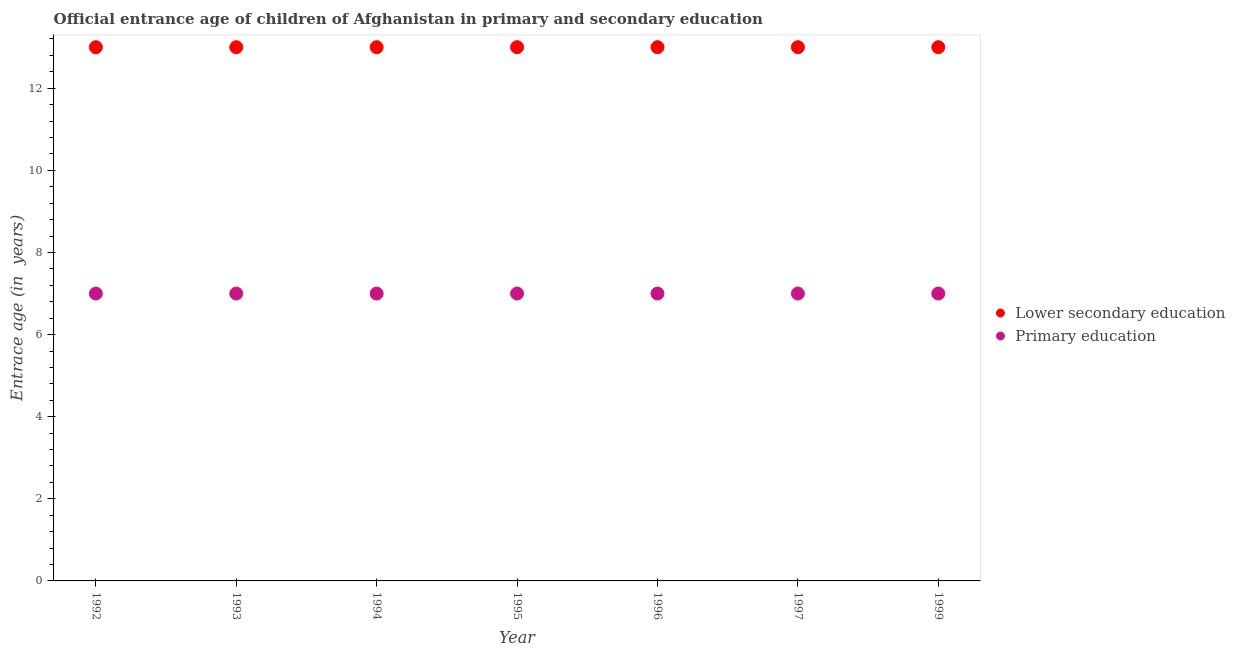What is the entrance age of children in lower secondary education in 1999?
Ensure brevity in your answer.  13. Across all years, what is the maximum entrance age of children in lower secondary education?
Your answer should be very brief. 13. Across all years, what is the minimum entrance age of children in lower secondary education?
Offer a terse response. 13. In which year was the entrance age of children in lower secondary education minimum?
Make the answer very short. 1992. What is the total entrance age of chiildren in primary education in the graph?
Provide a succinct answer. 49. What is the difference between the entrance age of chiildren in primary education in 1995 and that in 1999?
Offer a very short reply. 0. What is the difference between the entrance age of chiildren in primary education in 1995 and the entrance age of children in lower secondary education in 1992?
Keep it short and to the point. -6. In the year 1994, what is the difference between the entrance age of chiildren in primary education and entrance age of children in lower secondary education?
Your answer should be very brief. -6. In how many years, is the entrance age of children in lower secondary education greater than 4 years?
Provide a succinct answer. 7. Is the entrance age of chiildren in primary education in 1997 less than that in 1999?
Your answer should be compact. No. What is the difference between the highest and the second highest entrance age of children in lower secondary education?
Offer a terse response. 0. What is the difference between the highest and the lowest entrance age of children in lower secondary education?
Make the answer very short. 0. In how many years, is the entrance age of chiildren in primary education greater than the average entrance age of chiildren in primary education taken over all years?
Keep it short and to the point. 0. Does the entrance age of chiildren in primary education monotonically increase over the years?
Give a very brief answer. No. Is the entrance age of chiildren in primary education strictly less than the entrance age of children in lower secondary education over the years?
Make the answer very short. Yes. How many dotlines are there?
Provide a succinct answer. 2. How many legend labels are there?
Your response must be concise. 2. How are the legend labels stacked?
Your response must be concise. Vertical. What is the title of the graph?
Keep it short and to the point. Official entrance age of children of Afghanistan in primary and secondary education. What is the label or title of the Y-axis?
Ensure brevity in your answer.  Entrace age (in  years). What is the Entrace age (in  years) in Lower secondary education in 1992?
Your response must be concise. 13. What is the Entrace age (in  years) of Lower secondary education in 1995?
Give a very brief answer. 13. What is the Entrace age (in  years) in Lower secondary education in 1997?
Give a very brief answer. 13. What is the Entrace age (in  years) of Lower secondary education in 1999?
Your answer should be compact. 13. Across all years, what is the maximum Entrace age (in  years) in Primary education?
Ensure brevity in your answer.  7. What is the total Entrace age (in  years) of Lower secondary education in the graph?
Your response must be concise. 91. What is the difference between the Entrace age (in  years) of Primary education in 1992 and that in 1993?
Provide a succinct answer. 0. What is the difference between the Entrace age (in  years) in Lower secondary education in 1992 and that in 1994?
Give a very brief answer. 0. What is the difference between the Entrace age (in  years) in Primary education in 1992 and that in 1994?
Give a very brief answer. 0. What is the difference between the Entrace age (in  years) in Primary education in 1992 and that in 1995?
Your answer should be very brief. 0. What is the difference between the Entrace age (in  years) of Primary education in 1992 and that in 1996?
Provide a short and direct response. 0. What is the difference between the Entrace age (in  years) in Primary education in 1992 and that in 1997?
Make the answer very short. 0. What is the difference between the Entrace age (in  years) in Lower secondary education in 1992 and that in 1999?
Make the answer very short. 0. What is the difference between the Entrace age (in  years) of Lower secondary education in 1993 and that in 1994?
Keep it short and to the point. 0. What is the difference between the Entrace age (in  years) in Lower secondary education in 1993 and that in 1995?
Make the answer very short. 0. What is the difference between the Entrace age (in  years) of Lower secondary education in 1993 and that in 1997?
Make the answer very short. 0. What is the difference between the Entrace age (in  years) of Primary education in 1993 and that in 1997?
Offer a very short reply. 0. What is the difference between the Entrace age (in  years) of Primary education in 1994 and that in 1995?
Your answer should be compact. 0. What is the difference between the Entrace age (in  years) of Lower secondary education in 1994 and that in 1996?
Give a very brief answer. 0. What is the difference between the Entrace age (in  years) in Lower secondary education in 1994 and that in 1997?
Keep it short and to the point. 0. What is the difference between the Entrace age (in  years) of Primary education in 1994 and that in 1999?
Your answer should be very brief. 0. What is the difference between the Entrace age (in  years) in Lower secondary education in 1995 and that in 1996?
Keep it short and to the point. 0. What is the difference between the Entrace age (in  years) in Primary education in 1995 and that in 1996?
Provide a short and direct response. 0. What is the difference between the Entrace age (in  years) of Primary education in 1995 and that in 1997?
Provide a short and direct response. 0. What is the difference between the Entrace age (in  years) of Primary education in 1995 and that in 1999?
Your answer should be very brief. 0. What is the difference between the Entrace age (in  years) of Lower secondary education in 1996 and that in 1999?
Offer a very short reply. 0. What is the difference between the Entrace age (in  years) of Primary education in 1996 and that in 1999?
Ensure brevity in your answer.  0. What is the difference between the Entrace age (in  years) of Lower secondary education in 1992 and the Entrace age (in  years) of Primary education in 1994?
Provide a succinct answer. 6. What is the difference between the Entrace age (in  years) of Lower secondary education in 1992 and the Entrace age (in  years) of Primary education in 1995?
Ensure brevity in your answer.  6. What is the difference between the Entrace age (in  years) of Lower secondary education in 1992 and the Entrace age (in  years) of Primary education in 1996?
Ensure brevity in your answer.  6. What is the difference between the Entrace age (in  years) of Lower secondary education in 1992 and the Entrace age (in  years) of Primary education in 1999?
Keep it short and to the point. 6. What is the difference between the Entrace age (in  years) of Lower secondary education in 1993 and the Entrace age (in  years) of Primary education in 1995?
Offer a very short reply. 6. What is the difference between the Entrace age (in  years) of Lower secondary education in 1993 and the Entrace age (in  years) of Primary education in 1997?
Offer a very short reply. 6. What is the difference between the Entrace age (in  years) in Lower secondary education in 1994 and the Entrace age (in  years) in Primary education in 1995?
Give a very brief answer. 6. What is the difference between the Entrace age (in  years) in Lower secondary education in 1994 and the Entrace age (in  years) in Primary education in 1996?
Your answer should be compact. 6. What is the difference between the Entrace age (in  years) in Lower secondary education in 1994 and the Entrace age (in  years) in Primary education in 1999?
Provide a short and direct response. 6. What is the difference between the Entrace age (in  years) of Lower secondary education in 1995 and the Entrace age (in  years) of Primary education in 1996?
Provide a succinct answer. 6. What is the difference between the Entrace age (in  years) in Lower secondary education in 1996 and the Entrace age (in  years) in Primary education in 1997?
Provide a short and direct response. 6. What is the difference between the Entrace age (in  years) of Lower secondary education in 1996 and the Entrace age (in  years) of Primary education in 1999?
Provide a succinct answer. 6. What is the difference between the Entrace age (in  years) in Lower secondary education in 1997 and the Entrace age (in  years) in Primary education in 1999?
Offer a terse response. 6. What is the average Entrace age (in  years) in Lower secondary education per year?
Give a very brief answer. 13. What is the average Entrace age (in  years) in Primary education per year?
Ensure brevity in your answer.  7. In the year 1997, what is the difference between the Entrace age (in  years) of Lower secondary education and Entrace age (in  years) of Primary education?
Make the answer very short. 6. What is the ratio of the Entrace age (in  years) in Primary education in 1992 to that in 1993?
Offer a terse response. 1. What is the ratio of the Entrace age (in  years) of Primary education in 1992 to that in 1994?
Your answer should be compact. 1. What is the ratio of the Entrace age (in  years) in Lower secondary education in 1992 to that in 1995?
Provide a short and direct response. 1. What is the ratio of the Entrace age (in  years) of Lower secondary education in 1992 to that in 1996?
Offer a very short reply. 1. What is the ratio of the Entrace age (in  years) in Lower secondary education in 1992 to that in 1997?
Give a very brief answer. 1. What is the ratio of the Entrace age (in  years) in Lower secondary education in 1993 to that in 1996?
Give a very brief answer. 1. What is the ratio of the Entrace age (in  years) in Primary education in 1993 to that in 1996?
Offer a very short reply. 1. What is the ratio of the Entrace age (in  years) of Lower secondary education in 1993 to that in 1997?
Provide a succinct answer. 1. What is the ratio of the Entrace age (in  years) of Lower secondary education in 1993 to that in 1999?
Make the answer very short. 1. What is the ratio of the Entrace age (in  years) of Primary education in 1994 to that in 1995?
Ensure brevity in your answer.  1. What is the ratio of the Entrace age (in  years) in Primary education in 1994 to that in 1996?
Give a very brief answer. 1. What is the ratio of the Entrace age (in  years) of Primary education in 1994 to that in 1999?
Your answer should be very brief. 1. What is the ratio of the Entrace age (in  years) of Lower secondary education in 1995 to that in 1996?
Give a very brief answer. 1. What is the ratio of the Entrace age (in  years) of Primary education in 1995 to that in 1996?
Keep it short and to the point. 1. What is the ratio of the Entrace age (in  years) of Lower secondary education in 1995 to that in 1997?
Ensure brevity in your answer.  1. What is the ratio of the Entrace age (in  years) of Lower secondary education in 1995 to that in 1999?
Make the answer very short. 1. What is the ratio of the Entrace age (in  years) of Primary education in 1995 to that in 1999?
Ensure brevity in your answer.  1. What is the ratio of the Entrace age (in  years) in Lower secondary education in 1996 to that in 1997?
Your answer should be very brief. 1. What is the ratio of the Entrace age (in  years) in Primary education in 1996 to that in 1997?
Ensure brevity in your answer.  1. What is the ratio of the Entrace age (in  years) of Lower secondary education in 1996 to that in 1999?
Give a very brief answer. 1. What is the ratio of the Entrace age (in  years) of Primary education in 1997 to that in 1999?
Give a very brief answer. 1. What is the difference between the highest and the second highest Entrace age (in  years) in Lower secondary education?
Provide a short and direct response. 0. What is the difference between the highest and the second highest Entrace age (in  years) of Primary education?
Offer a very short reply. 0. What is the difference between the highest and the lowest Entrace age (in  years) of Lower secondary education?
Your answer should be compact. 0. 